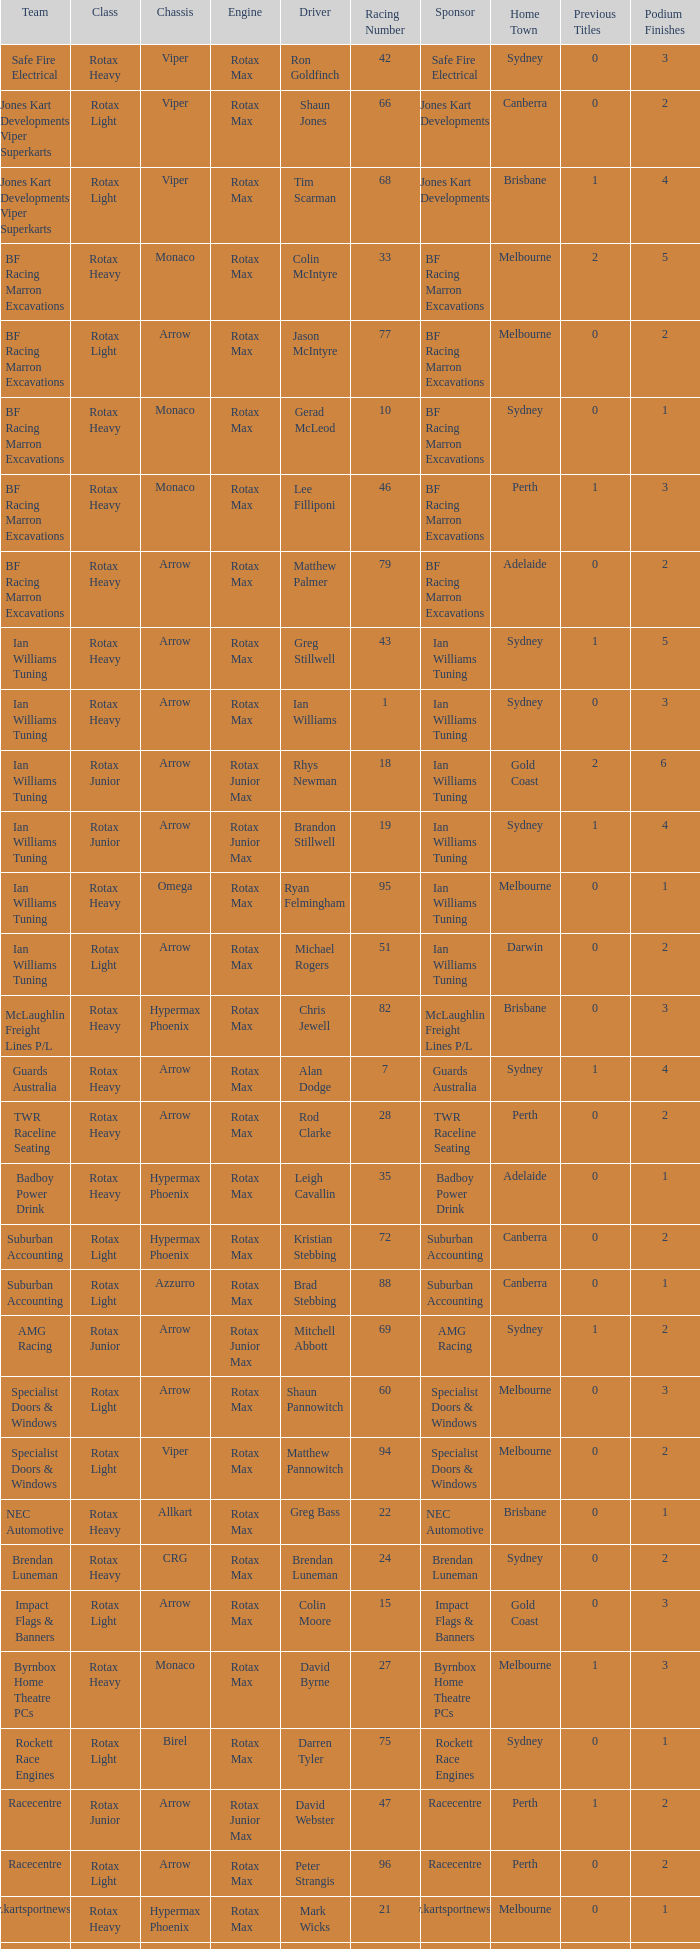Driver Shaun Jones with a viper as a chassis is in what class? Rotax Light. Parse the table in full. {'header': ['Team', 'Class', 'Chassis', 'Engine', 'Driver', 'Racing Number', 'Sponsor', 'Home Town', 'Previous Titles', 'Podium Finishes'], 'rows': [['Safe Fire Electrical', 'Rotax Heavy', 'Viper', 'Rotax Max', 'Ron Goldfinch', '42', 'Safe Fire Electrical', 'Sydney', '0', '3'], ['Jones Kart Developments Viper Superkarts', 'Rotax Light', 'Viper', 'Rotax Max', 'Shaun Jones', '66', 'Jones Kart Developments', 'Canberra', '0', '2'], ['Jones Kart Developments Viper Superkarts', 'Rotax Light', 'Viper', 'Rotax Max', 'Tim Scarman', '68', 'Jones Kart Developments', 'Brisbane', '1', '4'], ['BF Racing Marron Excavations', 'Rotax Heavy', 'Monaco', 'Rotax Max', 'Colin McIntyre', '33', 'BF Racing Marron Excavations', 'Melbourne', '2', '5'], ['BF Racing Marron Excavations', 'Rotax Light', 'Arrow', 'Rotax Max', 'Jason McIntyre', '77', 'BF Racing Marron Excavations', 'Melbourne', '0', '2'], ['BF Racing Marron Excavations', 'Rotax Heavy', 'Monaco', 'Rotax Max', 'Gerad McLeod', '10', 'BF Racing Marron Excavations', 'Sydney', '0', '1'], ['BF Racing Marron Excavations', 'Rotax Heavy', 'Monaco', 'Rotax Max', 'Lee Filliponi', '46', 'BF Racing Marron Excavations', 'Perth', '1', '3'], ['BF Racing Marron Excavations', 'Rotax Heavy', 'Arrow', 'Rotax Max', 'Matthew Palmer', '79', 'BF Racing Marron Excavations', 'Adelaide', '0', '2'], ['Ian Williams Tuning', 'Rotax Heavy', 'Arrow', 'Rotax Max', 'Greg Stillwell', '43', 'Ian Williams Tuning', 'Sydney', '1', '5'], ['Ian Williams Tuning', 'Rotax Heavy', 'Arrow', 'Rotax Max', 'Ian Williams', '1', 'Ian Williams Tuning', 'Sydney', '0', '3'], ['Ian Williams Tuning', 'Rotax Junior', 'Arrow', 'Rotax Junior Max', 'Rhys Newman', '18', 'Ian Williams Tuning', 'Gold Coast', '2', '6 '], ['Ian Williams Tuning', 'Rotax Junior', 'Arrow', 'Rotax Junior Max', 'Brandon Stillwell', '19', 'Ian Williams Tuning', 'Sydney', '1', '4'], ['Ian Williams Tuning', 'Rotax Heavy', 'Omega', 'Rotax Max', 'Ryan Felmingham', '95', 'Ian Williams Tuning', 'Melbourne', '0', '1'], ['Ian Williams Tuning', 'Rotax Light', 'Arrow', 'Rotax Max', 'Michael Rogers', '51', 'Ian Williams Tuning', 'Darwin', '0', '2'], ['McLaughlin Freight Lines P/L', 'Rotax Heavy', 'Hypermax Phoenix', 'Rotax Max', 'Chris Jewell', '82', 'McLaughlin Freight Lines P/L', 'Brisbane', '0', '3'], ['Guards Australia', 'Rotax Heavy', 'Arrow', 'Rotax Max', 'Alan Dodge', '7', 'Guards Australia', 'Sydney', '1', '4'], ['TWR Raceline Seating', 'Rotax Heavy', 'Arrow', 'Rotax Max', 'Rod Clarke', '28', 'TWR Raceline Seating', 'Perth', '0', '2'], ['Badboy Power Drink', 'Rotax Heavy', 'Hypermax Phoenix', 'Rotax Max', 'Leigh Cavallin', '35', 'Badboy Power Drink', 'Adelaide', '0', '1'], ['Suburban Accounting', 'Rotax Light', 'Hypermax Phoenix', 'Rotax Max', 'Kristian Stebbing', '72', 'Suburban Accounting', 'Canberra', '0', '2'], ['Suburban Accounting', 'Rotax Light', 'Azzurro', 'Rotax Max', 'Brad Stebbing', '88', 'Suburban Accounting', 'Canberra', '0', '1'], ['AMG Racing', 'Rotax Junior', 'Arrow', 'Rotax Junior Max', 'Mitchell Abbott', '69', 'AMG Racing', 'Sydney', '1', '2'], ['Specialist Doors & Windows', 'Rotax Light', 'Arrow', 'Rotax Max', 'Shaun Pannowitch', '60', 'Specialist Doors & Windows', 'Melbourne', '0', '3'], ['Specialist Doors & Windows', 'Rotax Light', 'Viper', 'Rotax Max', 'Matthew Pannowitch', '94', 'Specialist Doors & Windows', 'Melbourne', '0', '2'], ['NEC Automotive', 'Rotax Heavy', 'Allkart', 'Rotax Max', 'Greg Bass', '22', 'NEC Automotive', 'Brisbane', '0', '1'], ['Brendan Luneman', 'Rotax Heavy', 'CRG', 'Rotax Max', 'Brendan Luneman', '24', 'Brendan Luneman', 'Sydney', '0', '2'], ['Impact Flags & Banners', 'Rotax Light', 'Arrow', 'Rotax Max', 'Colin Moore', '15', 'Impact Flags & Banners', 'Gold Coast', '0', '3'], ['Byrnbox Home Theatre PCs', 'Rotax Heavy', 'Monaco', 'Rotax Max', 'David Byrne', '27', 'Byrnbox Home Theatre PCs', 'Melbourne', '1', '3'], ['Rockett Race Engines', 'Rotax Light', 'Birel', 'Rotax Max', 'Darren Tyler', '75', 'Rockett Race Engines', 'Sydney', '0', '1'], ['Racecentre', 'Rotax Junior', 'Arrow', 'Rotax Junior Max', 'David Webster', '47', 'Racecentre', 'Perth', '1', '2'], ['Racecentre', 'Rotax Light', 'Arrow', 'Rotax Max', 'Peter Strangis', '96', 'Racecentre', 'Perth', '0', '2'], ['www.kartsportnews.com', 'Rotax Heavy', 'Hypermax Phoenix', 'Rotax Max', 'Mark Wicks', '21', 'www.kartsportnews.com', 'Melbourne', '0', '1'], ['Doug Savage', 'Rotax Light', 'Arrow', 'Rotax Max', 'Doug Savage', '91', 'Doug Savage', 'Adelaide', '0', '0'], ['Race Stickerz Toyota Material Handling', 'Rotax Heavy', 'Techno', 'Rotax Max', 'Scott Appledore', '44', 'Race Stickerz Toyota Material Handling', 'Sydney', '0', '2'], ['Wild Digital', 'Rotax Junior', 'Hypermax Phoenix', 'Rotax Junior Max', 'Sean Whitfield', '11', 'Wild Digital', 'Gold Coast', '0', '1'], ['John Bartlett', 'Rotax Heavy', 'Hypermax Phoenix', 'Rotax Max', 'John Bartlett', '62', 'John Bartlett', 'Gold Coast', '0', '0']]} 